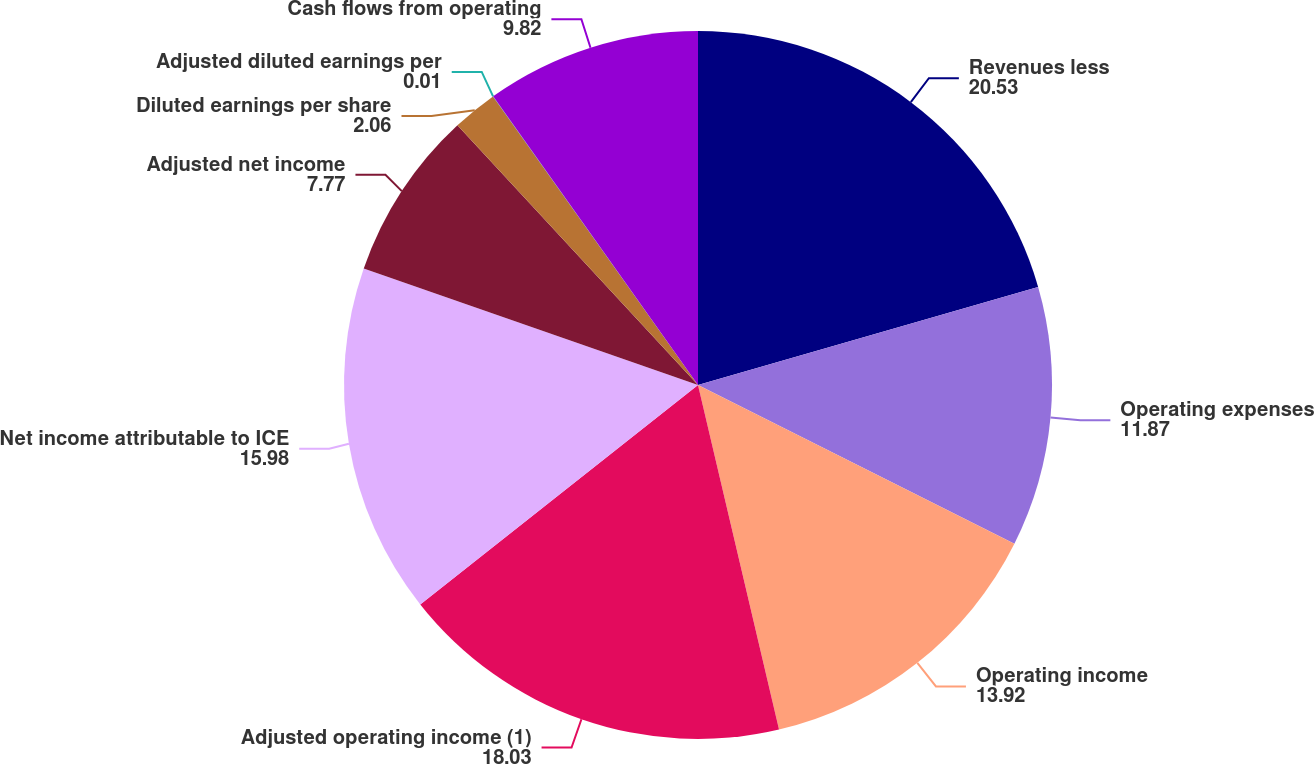<chart> <loc_0><loc_0><loc_500><loc_500><pie_chart><fcel>Revenues less<fcel>Operating expenses<fcel>Operating income<fcel>Adjusted operating income (1)<fcel>Net income attributable to ICE<fcel>Adjusted net income<fcel>Diluted earnings per share<fcel>Adjusted diluted earnings per<fcel>Cash flows from operating<nl><fcel>20.53%<fcel>11.87%<fcel>13.92%<fcel>18.03%<fcel>15.98%<fcel>7.77%<fcel>2.06%<fcel>0.01%<fcel>9.82%<nl></chart> 